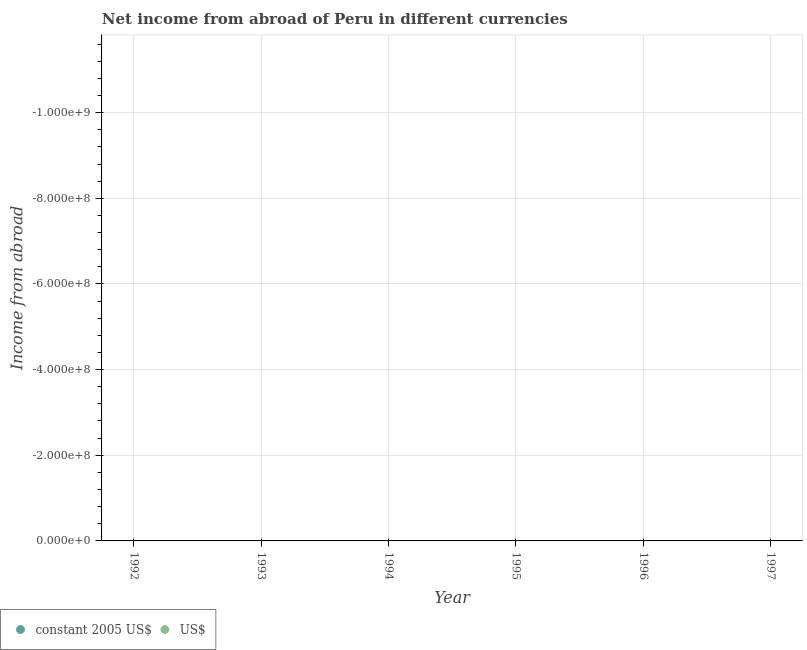Is the number of dotlines equal to the number of legend labels?
Make the answer very short. No. What is the income from abroad in us$ in 1997?
Your answer should be compact. 0. What is the difference between the income from abroad in constant 2005 us$ in 1993 and the income from abroad in us$ in 1995?
Your answer should be very brief. 0. Does the income from abroad in us$ monotonically increase over the years?
Ensure brevity in your answer.  No. Is the income from abroad in us$ strictly greater than the income from abroad in constant 2005 us$ over the years?
Keep it short and to the point. Yes. Is the income from abroad in us$ strictly less than the income from abroad in constant 2005 us$ over the years?
Your answer should be very brief. No. How many dotlines are there?
Offer a terse response. 0. Does the graph contain any zero values?
Ensure brevity in your answer.  Yes. Where does the legend appear in the graph?
Offer a terse response. Bottom left. How are the legend labels stacked?
Make the answer very short. Horizontal. What is the title of the graph?
Ensure brevity in your answer.  Net income from abroad of Peru in different currencies. Does "Underweight" appear as one of the legend labels in the graph?
Keep it short and to the point. No. What is the label or title of the Y-axis?
Ensure brevity in your answer.  Income from abroad. What is the Income from abroad in constant 2005 US$ in 1992?
Your answer should be compact. 0. What is the Income from abroad of US$ in 1993?
Provide a short and direct response. 0. What is the Income from abroad in US$ in 1994?
Your answer should be very brief. 0. What is the Income from abroad of US$ in 1995?
Ensure brevity in your answer.  0. What is the Income from abroad of US$ in 1997?
Provide a succinct answer. 0. What is the total Income from abroad in constant 2005 US$ in the graph?
Provide a succinct answer. 0. What is the average Income from abroad in constant 2005 US$ per year?
Make the answer very short. 0. 